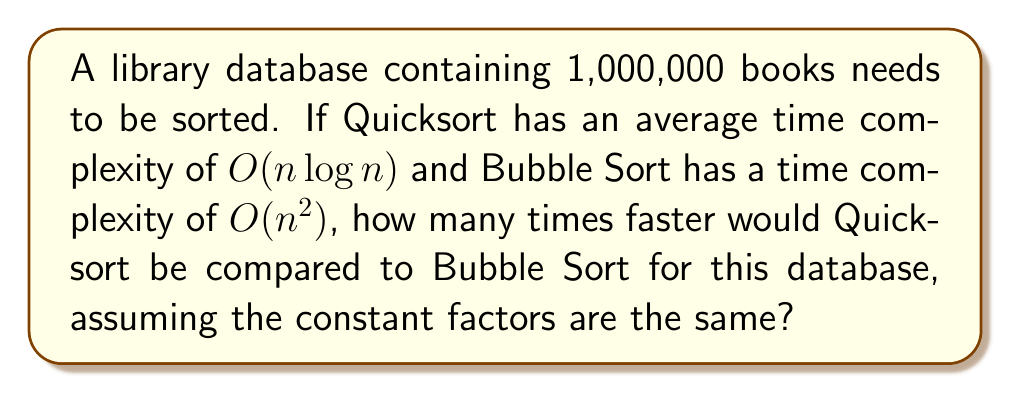Teach me how to tackle this problem. Let's approach this step-by-step:

1) For Quicksort:
   Time complexity = $O(n \log n)$
   $n = 1,000,000$
   
   $$T_{quick} = k \cdot 1,000,000 \cdot \log(1,000,000)$$
   
   where $k$ is some constant factor.

2) For Bubble Sort:
   Time complexity = $O(n^2)$
   $n = 1,000,000$
   
   $$T_{bubble} = k \cdot (1,000,000)^2$$
   
   Using the same constant factor $k$ for simplicity.

3) To find how many times faster Quicksort is, we divide $T_{bubble}$ by $T_{quick}$:

   $$\frac{T_{bubble}}{T_{quick}} = \frac{k \cdot (1,000,000)^2}{k \cdot 1,000,000 \cdot \log(1,000,000)}$$

4) The $k$ cancels out:

   $$\frac{T_{bubble}}{T_{quick}} = \frac{1,000,000}{\log(1,000,000)}$$

5) $\log(1,000,000)$ is approximately 20 (using base 2 logarithm):

   $$\frac{T_{bubble}}{T_{quick}} \approx \frac{1,000,000}{20} = 50,000$$

Thus, Quicksort would be approximately 50,000 times faster than Bubble Sort for this database size.
Answer: 50,000 times faster 